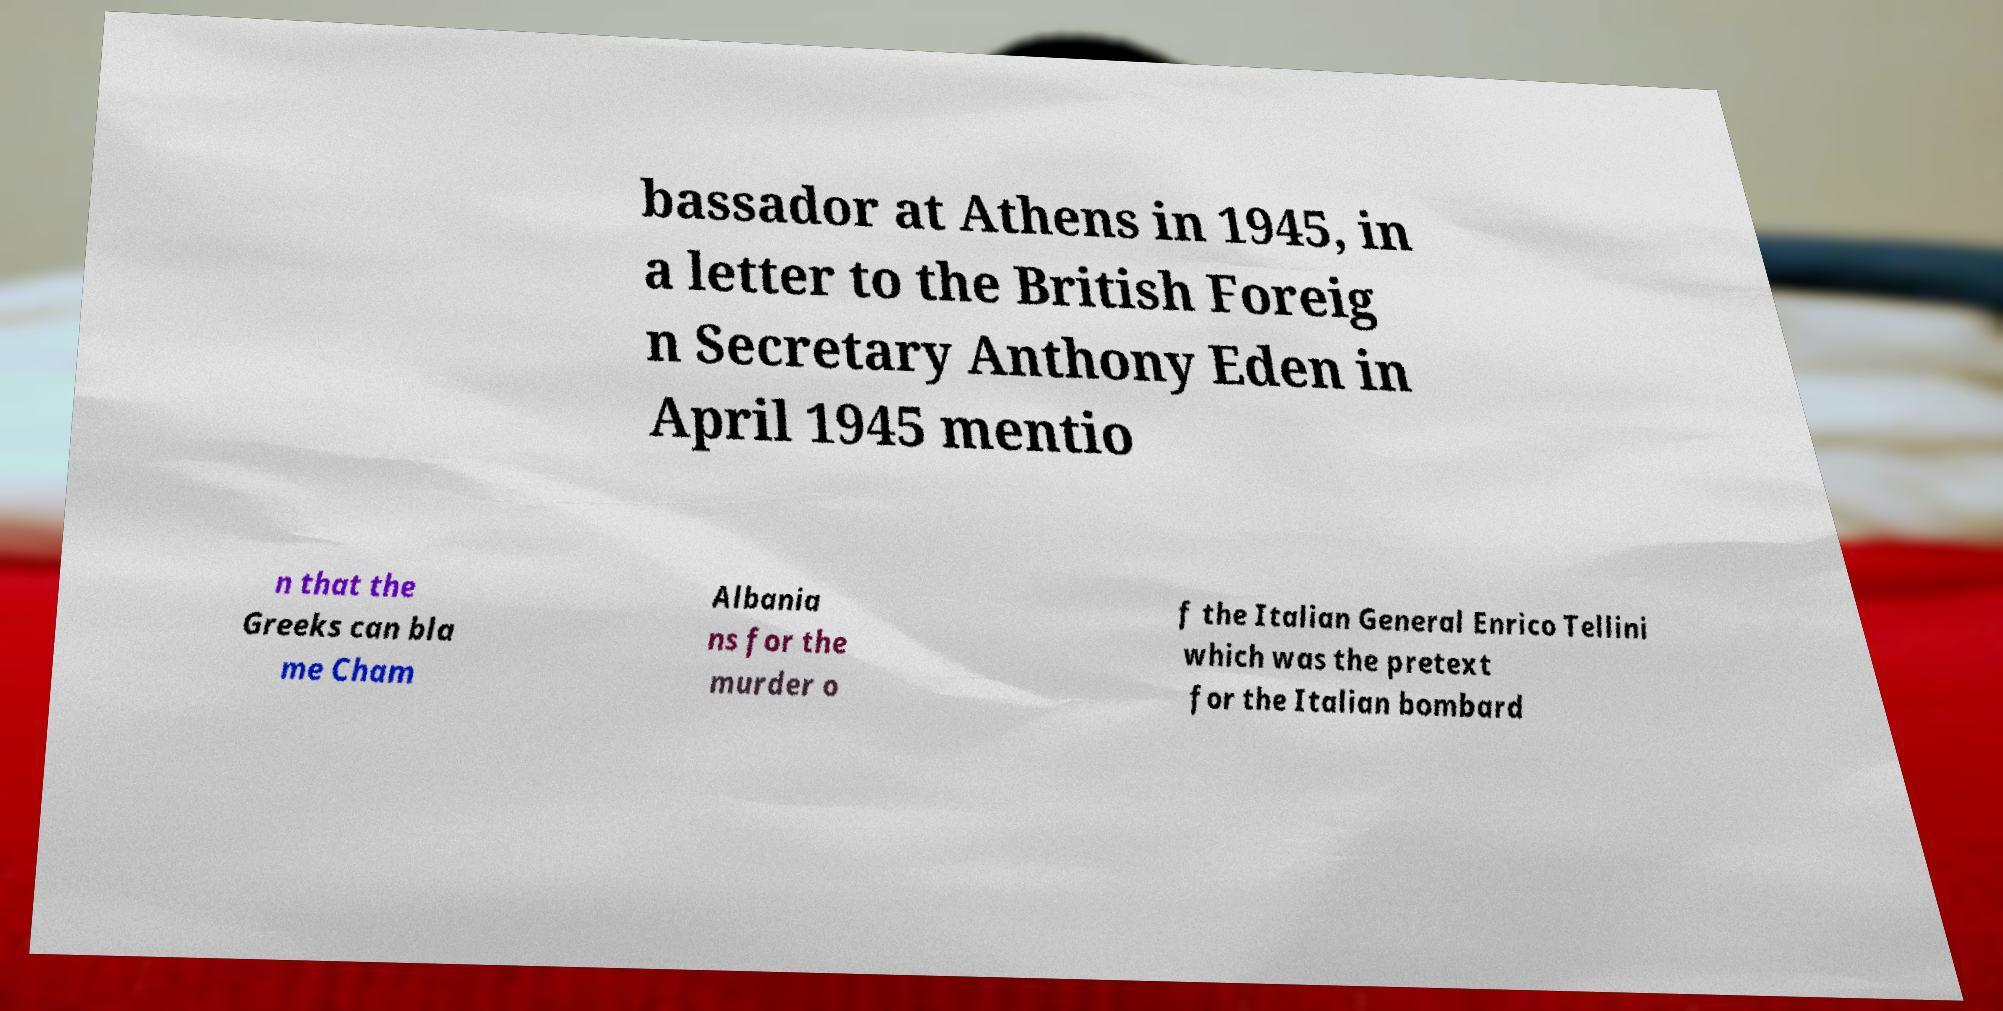Could you assist in decoding the text presented in this image and type it out clearly? bassador at Athens in 1945, in a letter to the British Foreig n Secretary Anthony Eden in April 1945 mentio n that the Greeks can bla me Cham Albania ns for the murder o f the Italian General Enrico Tellini which was the pretext for the Italian bombard 